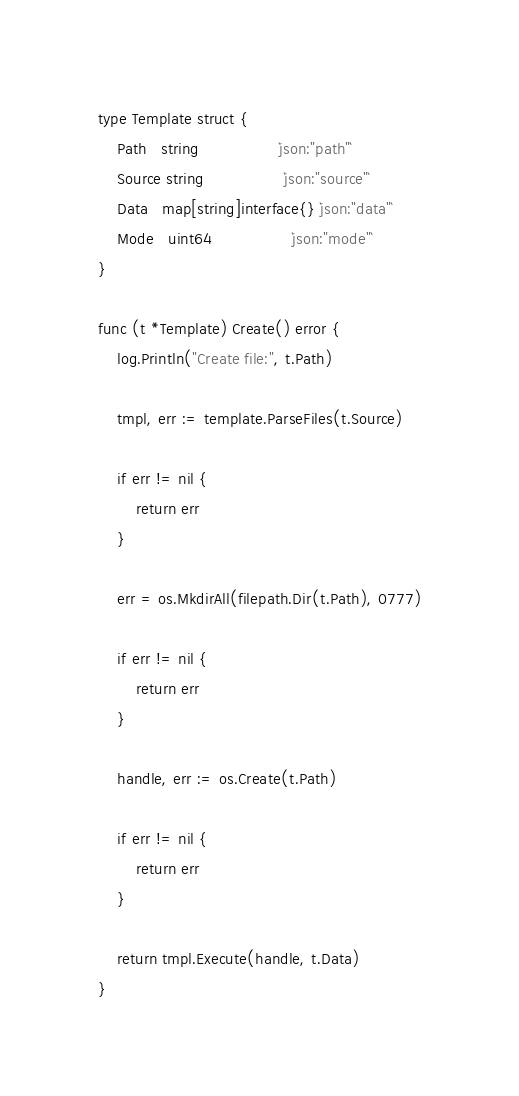<code> <loc_0><loc_0><loc_500><loc_500><_Go_>type Template struct {
	Path   string                 `json:"path"`
	Source string                 `json:"source"`
	Data   map[string]interface{} `json:"data"`
	Mode   uint64                 `json:"mode"`
}

func (t *Template) Create() error {
	log.Println("Create file:", t.Path)

	tmpl, err := template.ParseFiles(t.Source)

	if err != nil {
		return err
	}

	err = os.MkdirAll(filepath.Dir(t.Path), 0777)

	if err != nil {
		return err
	}

	handle, err := os.Create(t.Path)

	if err != nil {
		return err
	}

	return tmpl.Execute(handle, t.Data)
}
</code> 